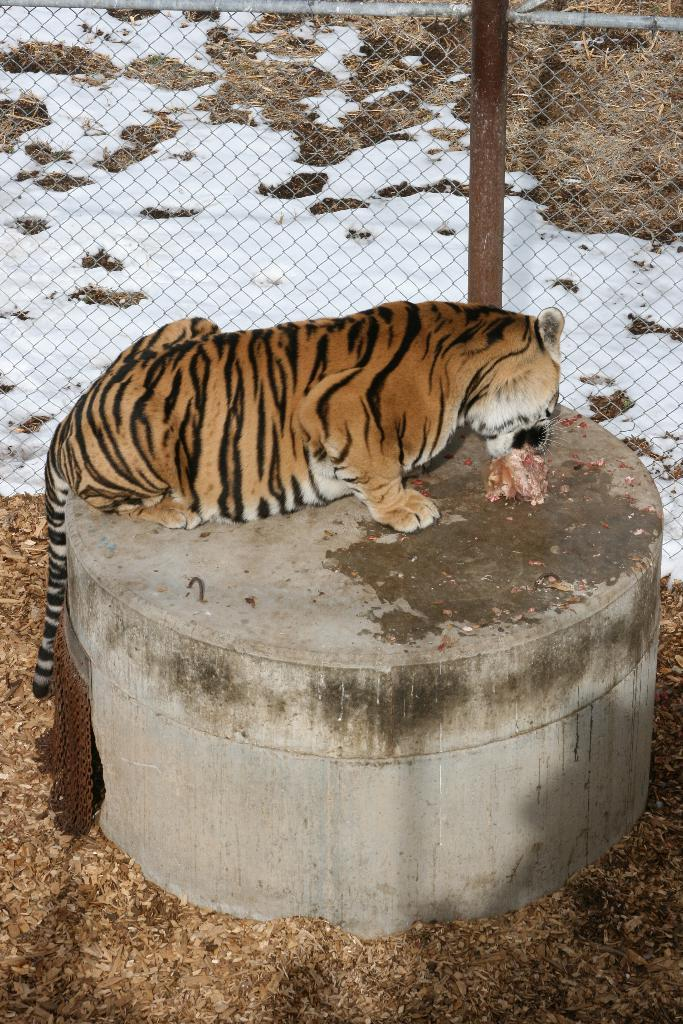What animal is present in the image? There is a tiger in the image. What is the tiger doing in the image? The tiger is eating something in the image. How is the object being eaten positioned? The object being eaten is on a cylindrical shaped platform. What type of environment is depicted in the image? There is snow and grass visible in the image. What type of barrier is present in the image? There is a wire fence in the image. What type of picture is hanging on the wall in the image? There is no wall or picture present in the image; it features a tiger in a snowy and grassy environment with a wire fence. What type of vase is visible on the table in the image? There is no table or vase present in the image; it features a tiger in a snowy and grassy environment with a wire fence. 